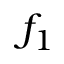Convert formula to latex. <formula><loc_0><loc_0><loc_500><loc_500>f _ { 1 }</formula> 